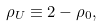Convert formula to latex. <formula><loc_0><loc_0><loc_500><loc_500>\rho _ { U } \equiv 2 - \rho _ { 0 } ,</formula> 